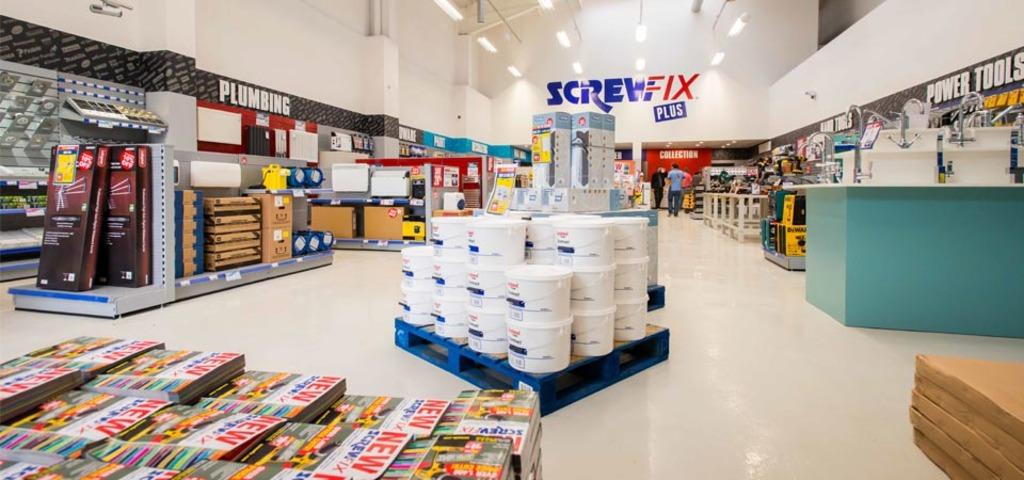<image>
Provide a brief description of the given image. Supermarket selling buckets in the front and a Screw Fix Plus near the back. 